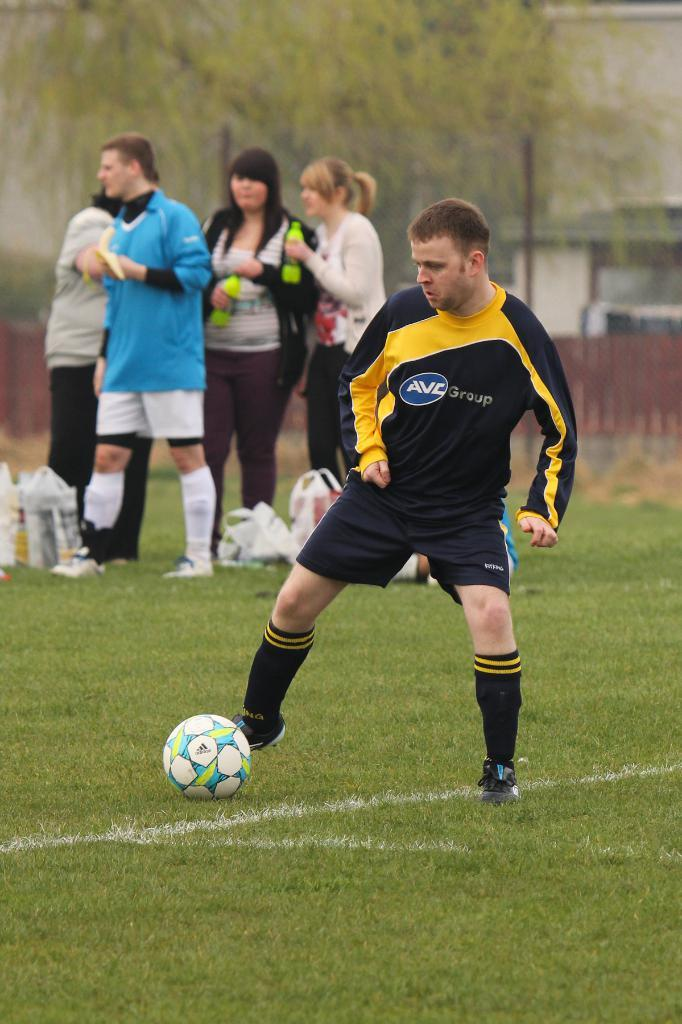What is the man in the image doing? The man is kicking a football in the image. Can you describe the people behind the man? The people in the group are holding bottles. What can be seen in the background of the image? There are trees present in the image. How many fingers does the football have in the image? The football does not have fingers, as it is an inanimate object. 